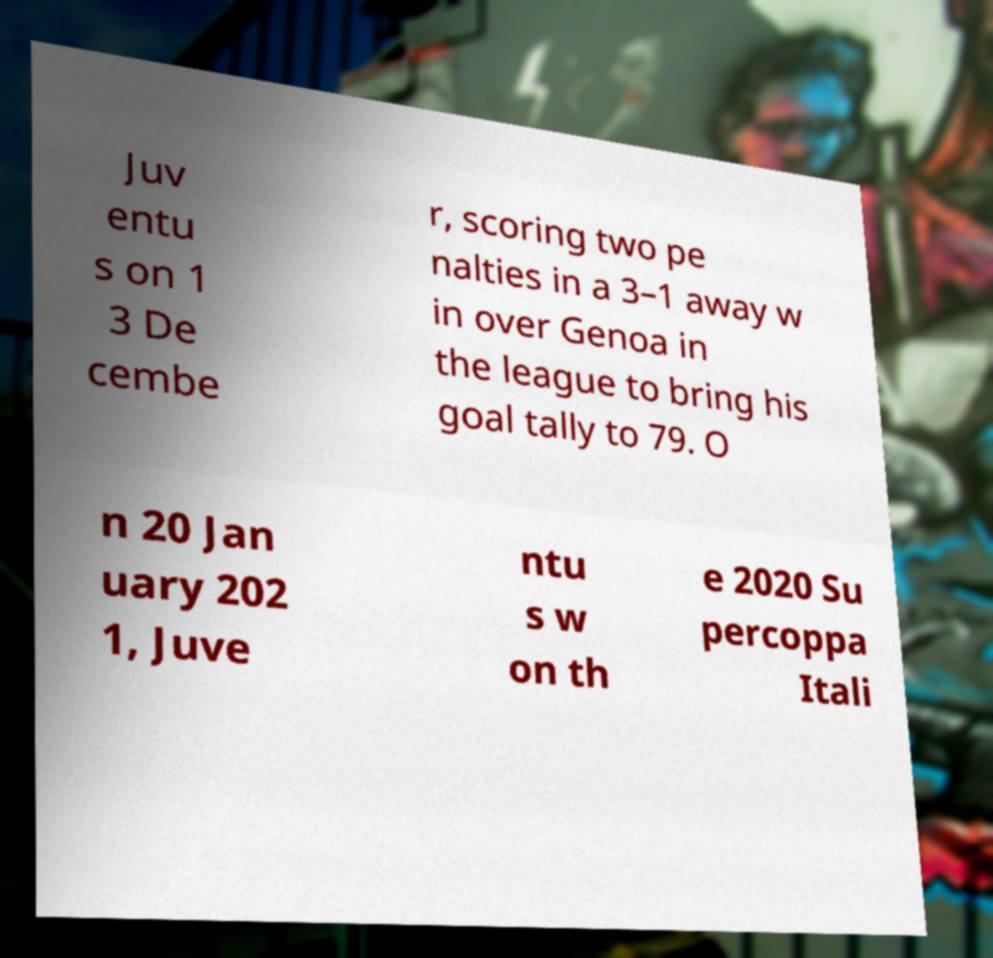Please read and relay the text visible in this image. What does it say? Juv entu s on 1 3 De cembe r, scoring two pe nalties in a 3–1 away w in over Genoa in the league to bring his goal tally to 79. O n 20 Jan uary 202 1, Juve ntu s w on th e 2020 Su percoppa Itali 